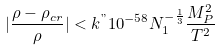Convert formula to latex. <formula><loc_0><loc_0><loc_500><loc_500>| \frac { \rho - \rho _ { c r } } { \rho } | < k ^ { " } 1 0 ^ { - 5 8 } N _ { 1 } ^ { - \frac { 1 } { 3 } } \frac { M _ { P } ^ { 2 } } { T ^ { 2 } }</formula> 